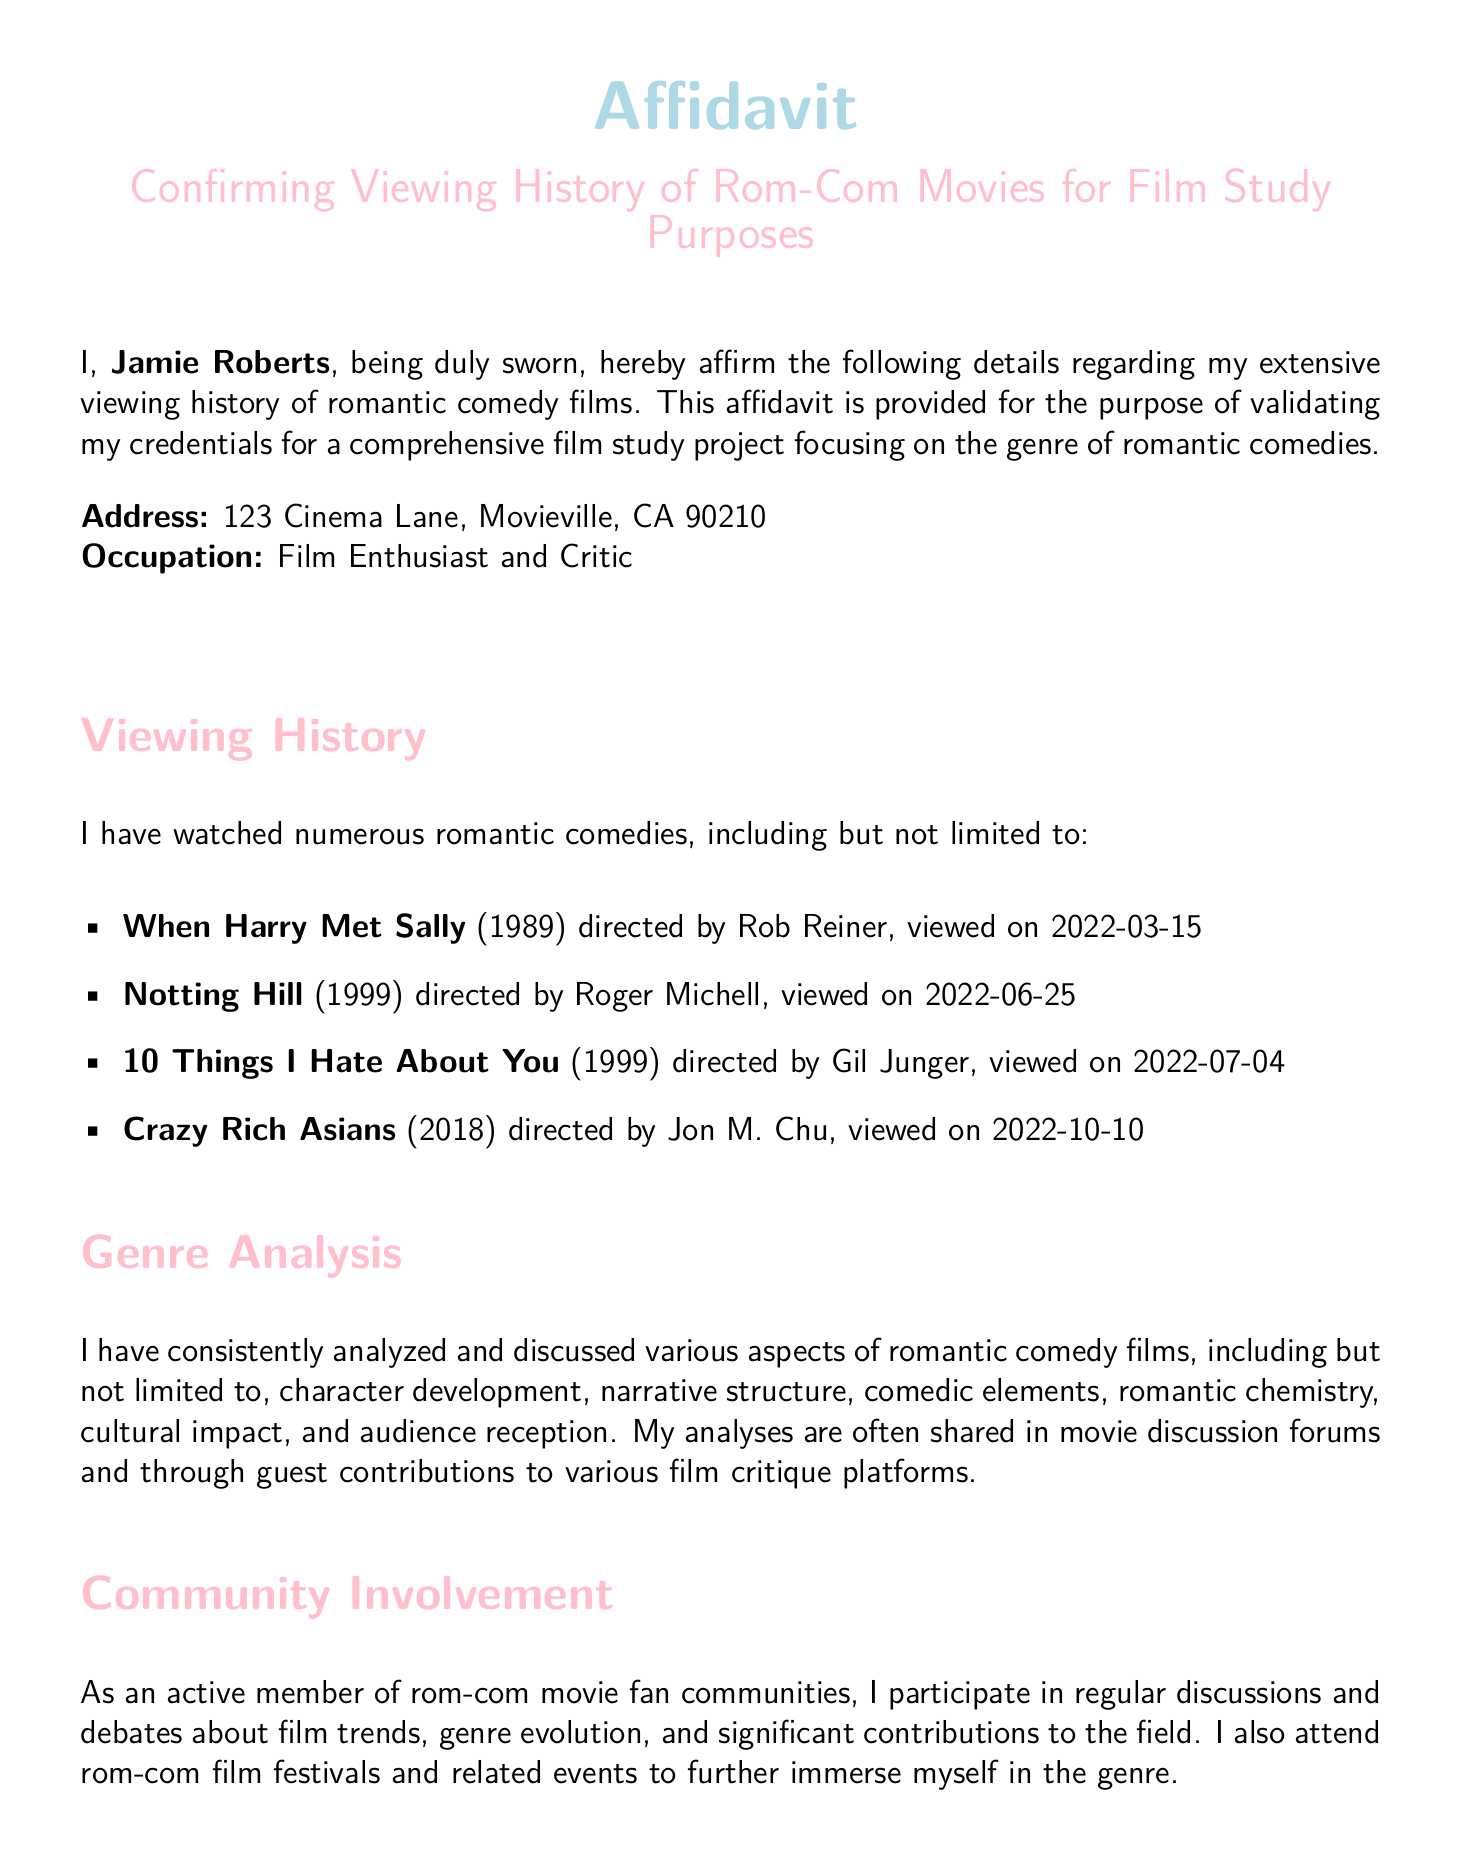what is the name of the affiant? The affiant's name is stated at the beginning of the affidavit as Jamie Roberts.
Answer: Jamie Roberts what is the address provided in the affidavit? The address is explicitly mentioned in the document under the field "Address."
Answer: 123 Cinema Lane, Movieville, CA 90210 what is the date of the viewing of 'Crazy Rich Asians'? The date when 'Crazy Rich Asians' was viewed is detailed in the viewing history section.
Answer: 2022-10-10 how many romantic comedies are listed in the viewing history? The number of films listed can be counted from the itemized list in the document.
Answer: 4 what occupation is stated in the affidavit? The occupation is explicitly listed in the document as part of the personal information provided.
Answer: Film Enthusiast and Critic what genre does Jamie Roberts analyze and discuss in the affidavit? The genre that Jamie Roberts focuses on for analysis is specified in the document.
Answer: Romantic comedy who directed 'Notting Hill'? The name of the director is provided next to the film title in the viewing history section.
Answer: Roger Michell what is the purpose of this affidavit? The purpose is stated clearly at the beginning of the document.
Answer: Validating credentials for a film study project 